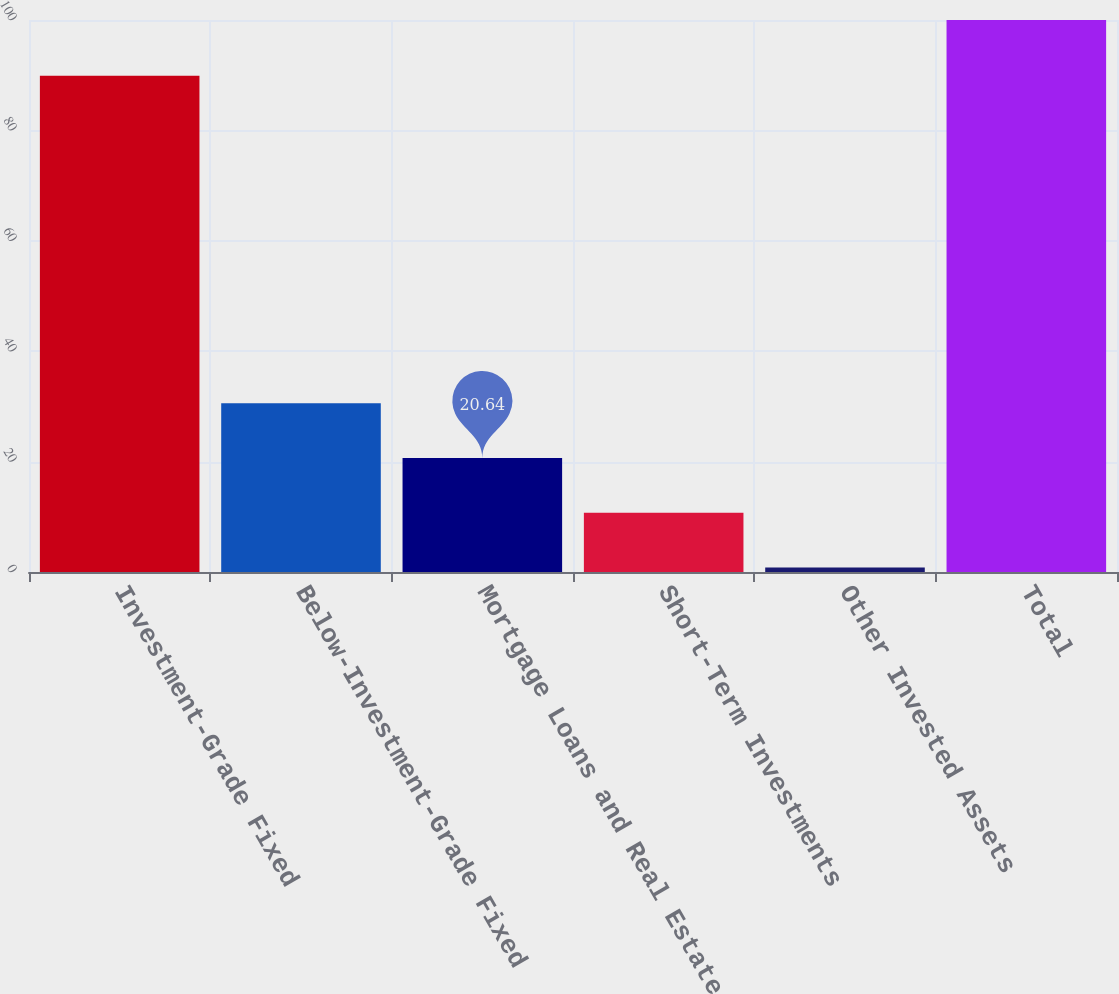Convert chart. <chart><loc_0><loc_0><loc_500><loc_500><bar_chart><fcel>Investment-Grade Fixed<fcel>Below-Investment-Grade Fixed<fcel>Mortgage Loans and Real Estate<fcel>Short-Term Investments<fcel>Other Invested Assets<fcel>Total<nl><fcel>89.9<fcel>30.56<fcel>20.64<fcel>10.72<fcel>0.8<fcel>100<nl></chart> 